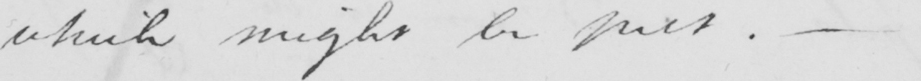Please transcribe the handwritten text in this image. which might be put .  _ 